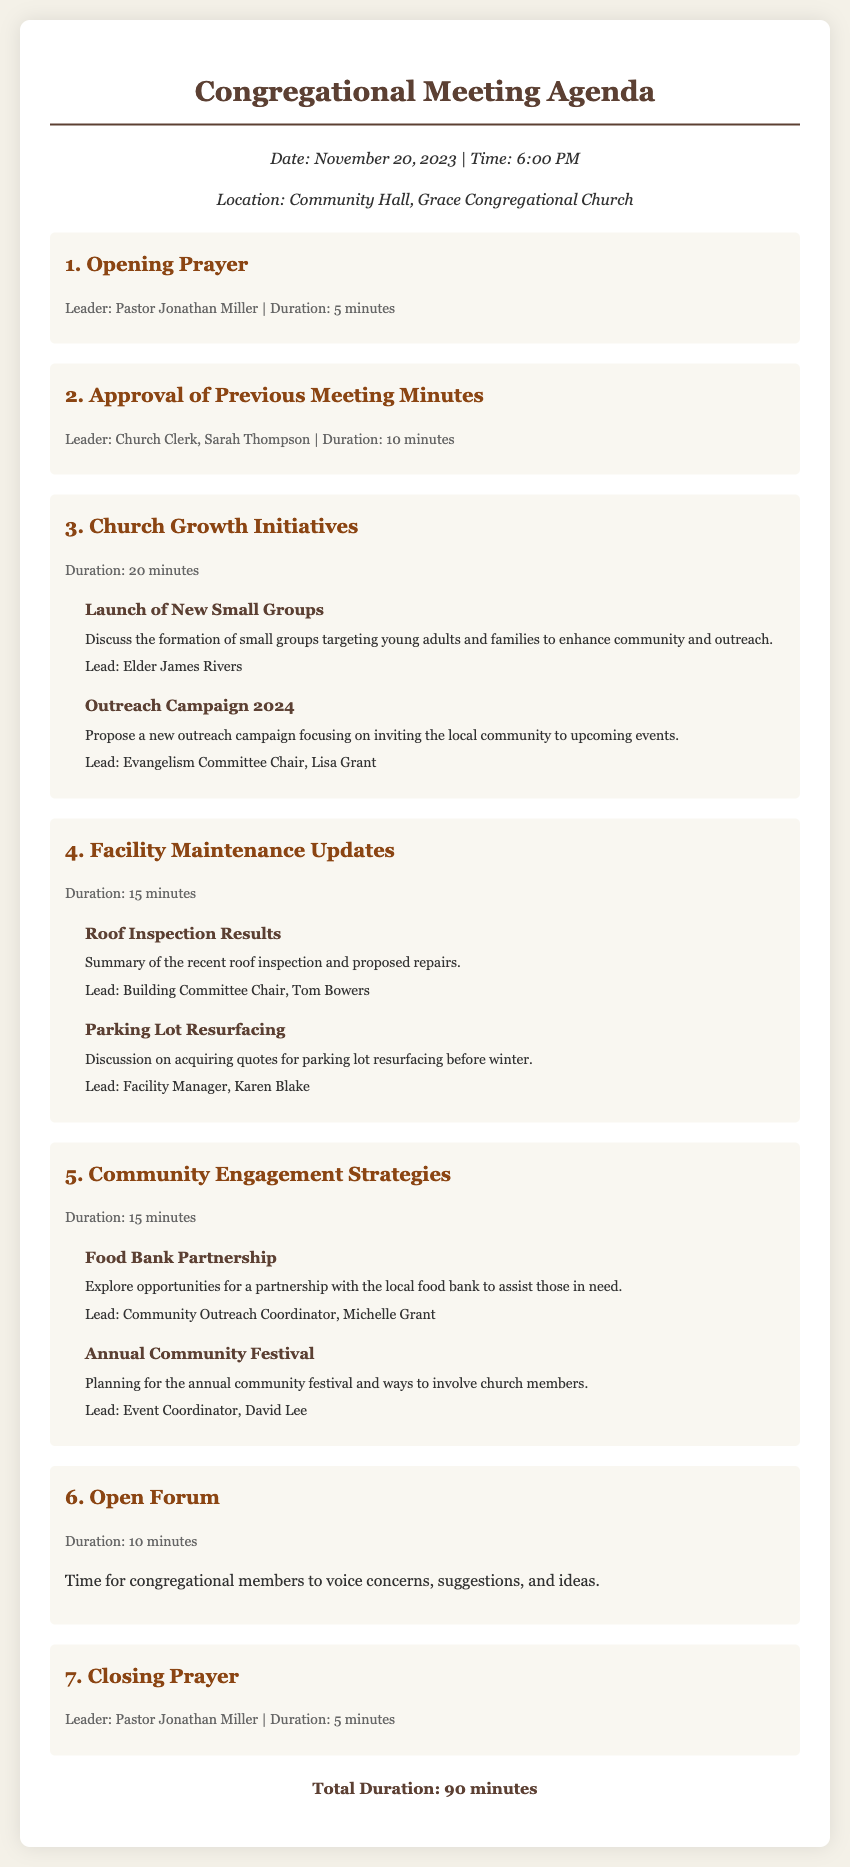What is the date of the meeting? The date of the meeting is specified in the document as "November 20, 2023."
Answer: November 20, 2023 Who leads the opening prayer? The document states that Pastor Jonathan Miller leads the opening prayer.
Answer: Pastor Jonathan Miller What is the duration of the Church Growth Initiatives discussion? The document outlines that the duration for Church Growth Initiatives is 20 minutes.
Answer: 20 minutes What is one of the topics covered under Facility Maintenance Updates? The document lists "Roof Inspection Results" as one of the topics under Facility Maintenance Updates.
Answer: Roof Inspection Results How long is the Open Forum scheduled for? According to the agenda, the Open Forum is scheduled for 10 minutes.
Answer: 10 minutes Name the leader responsible for the Food Bank Partnership discussion. The document identifies Michelle Grant as the community outreach coordinator leading the Food Bank Partnership discussion.
Answer: Michelle Grant What is the total duration of the meeting? The total duration is calculated at the end of the document, which states it is 90 minutes.
Answer: 90 minutes What is the main focus of the outreach campaign proposed? The document describes the outreach campaign as focusing on inviting the local community to upcoming events.
Answer: Inviting the local community to upcoming events 